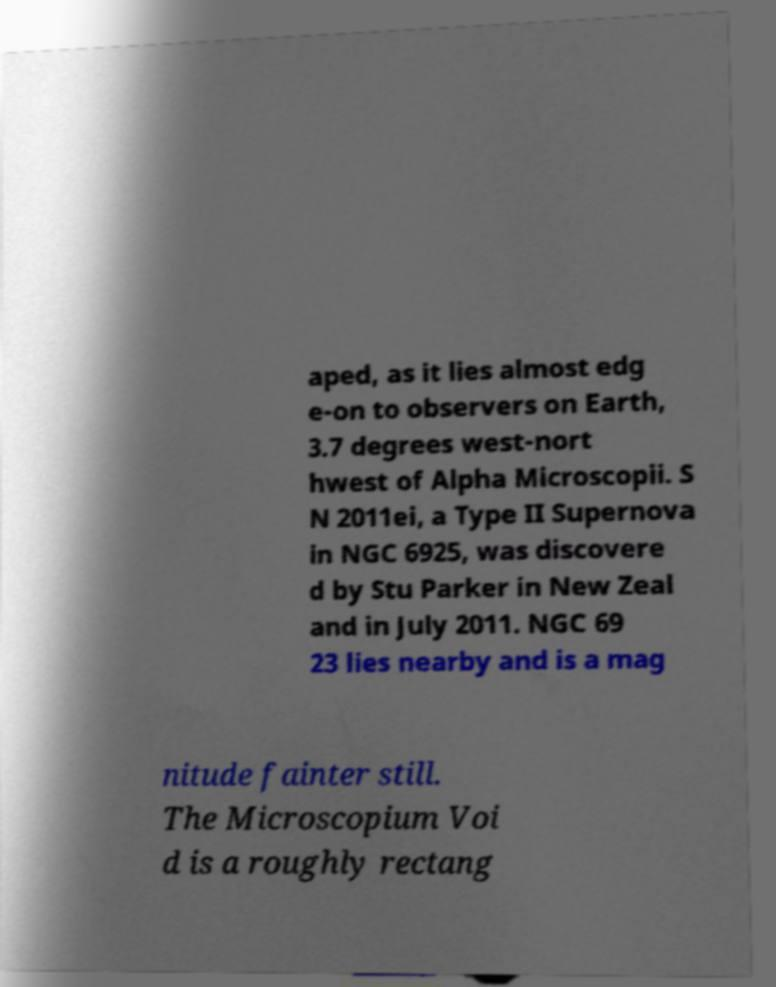There's text embedded in this image that I need extracted. Can you transcribe it verbatim? aped, as it lies almost edg e-on to observers on Earth, 3.7 degrees west-nort hwest of Alpha Microscopii. S N 2011ei, a Type II Supernova in NGC 6925, was discovere d by Stu Parker in New Zeal and in July 2011. NGC 69 23 lies nearby and is a mag nitude fainter still. The Microscopium Voi d is a roughly rectang 